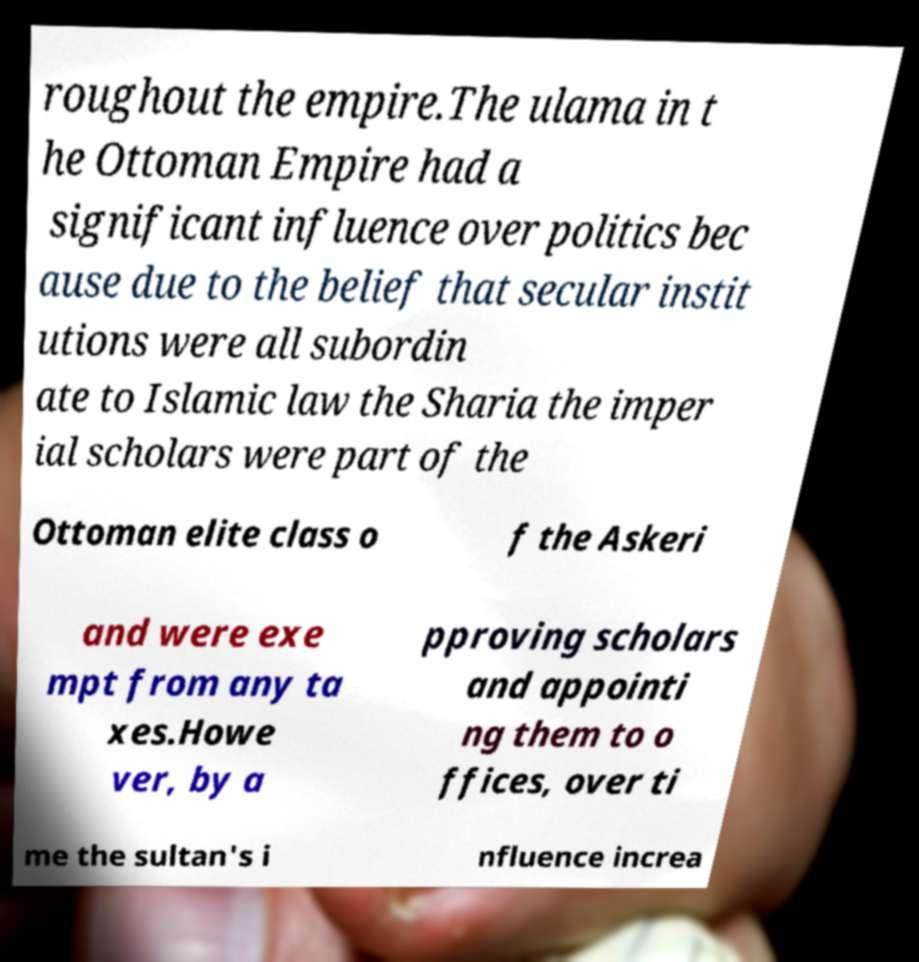Can you accurately transcribe the text from the provided image for me? roughout the empire.The ulama in t he Ottoman Empire had a significant influence over politics bec ause due to the belief that secular instit utions were all subordin ate to Islamic law the Sharia the imper ial scholars were part of the Ottoman elite class o f the Askeri and were exe mpt from any ta xes.Howe ver, by a pproving scholars and appointi ng them to o ffices, over ti me the sultan's i nfluence increa 